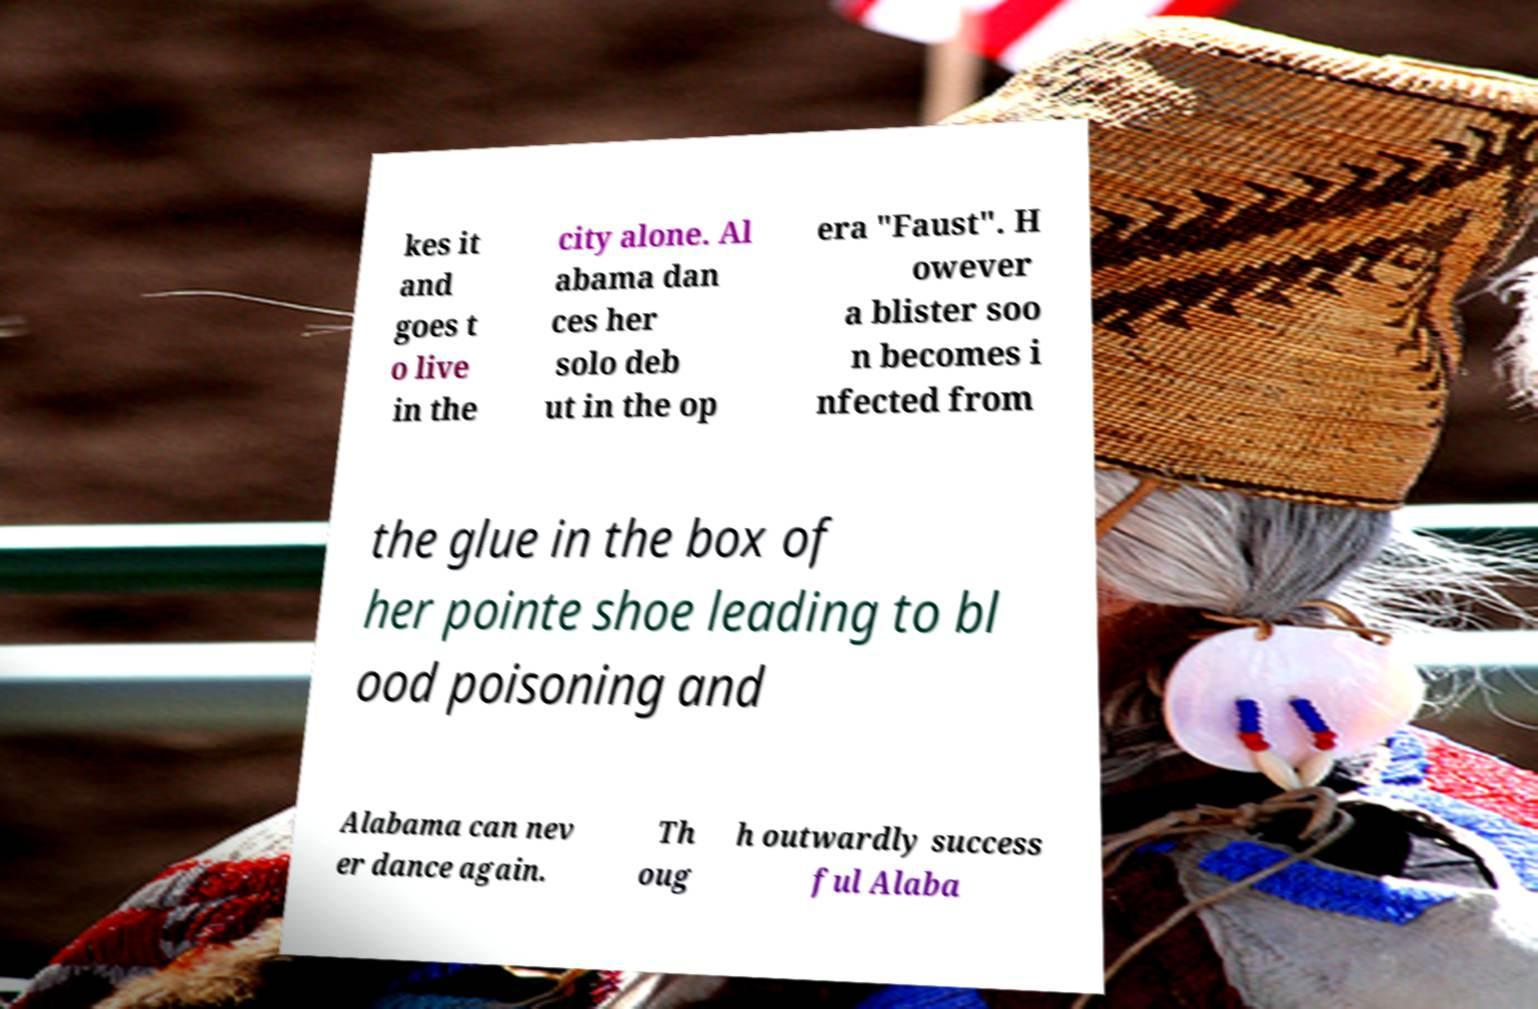What messages or text are displayed in this image? I need them in a readable, typed format. kes it and goes t o live in the city alone. Al abama dan ces her solo deb ut in the op era "Faust". H owever a blister soo n becomes i nfected from the glue in the box of her pointe shoe leading to bl ood poisoning and Alabama can nev er dance again. Th oug h outwardly success ful Alaba 